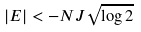<formula> <loc_0><loc_0><loc_500><loc_500>| E | < - N J \sqrt { \log 2 }</formula> 